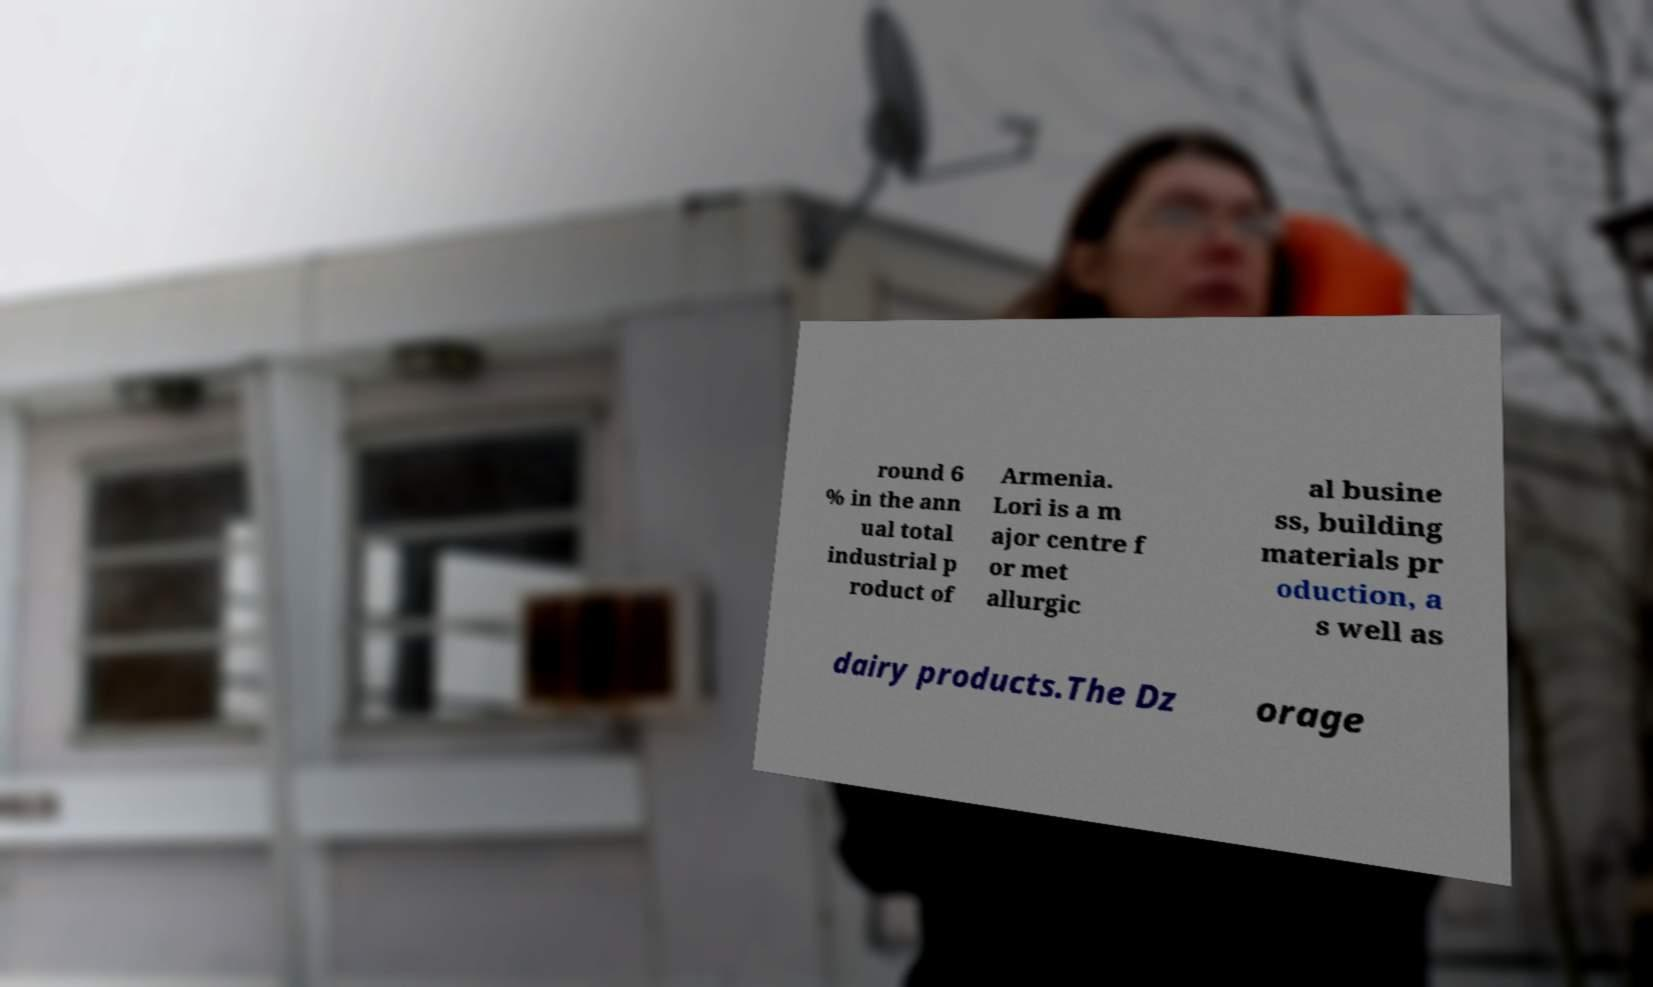Can you accurately transcribe the text from the provided image for me? round 6 % in the ann ual total industrial p roduct of Armenia. Lori is a m ajor centre f or met allurgic al busine ss, building materials pr oduction, a s well as dairy products.The Dz orage 